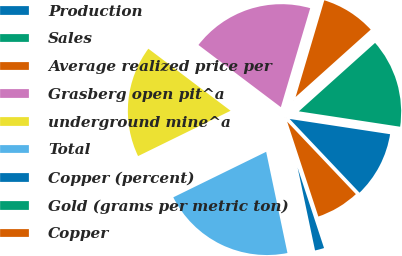Convert chart to OTSL. <chart><loc_0><loc_0><loc_500><loc_500><pie_chart><fcel>Production<fcel>Sales<fcel>Average realized price per<fcel>Grasberg open pit^a<fcel>underground mine^a<fcel>Total<fcel>Copper (percent)<fcel>Gold (grams per metric ton)<fcel>Copper<nl><fcel>10.53%<fcel>14.04%<fcel>8.77%<fcel>19.3%<fcel>17.54%<fcel>21.05%<fcel>1.75%<fcel>0.0%<fcel>7.02%<nl></chart> 